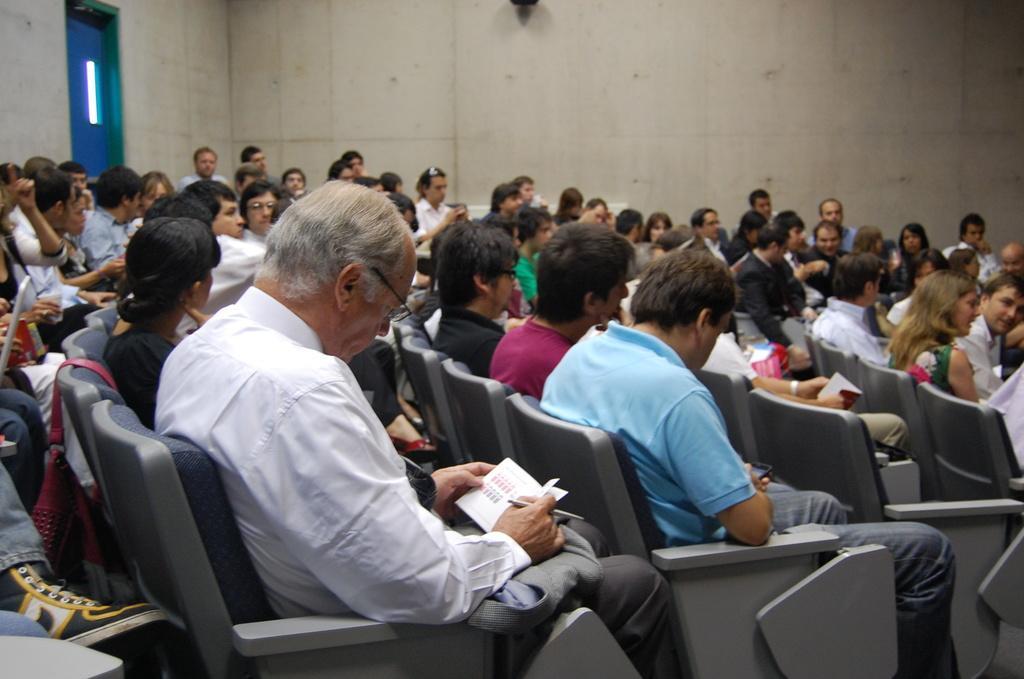How would you summarize this image in a sentence or two? In this picture we can see a group of people sitting on chairs, books, pen, bag and in the background we can see the wall. 